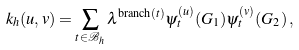<formula> <loc_0><loc_0><loc_500><loc_500>k _ { h } ( u , v ) = \sum _ { t \in \mathcal { B } _ { h } } \lambda ^ { \text {branch} ( t ) } \psi ^ { ( u ) } _ { t } ( G _ { 1 } ) \psi ^ { ( v ) } _ { t } ( G _ { 2 } ) \, ,</formula> 